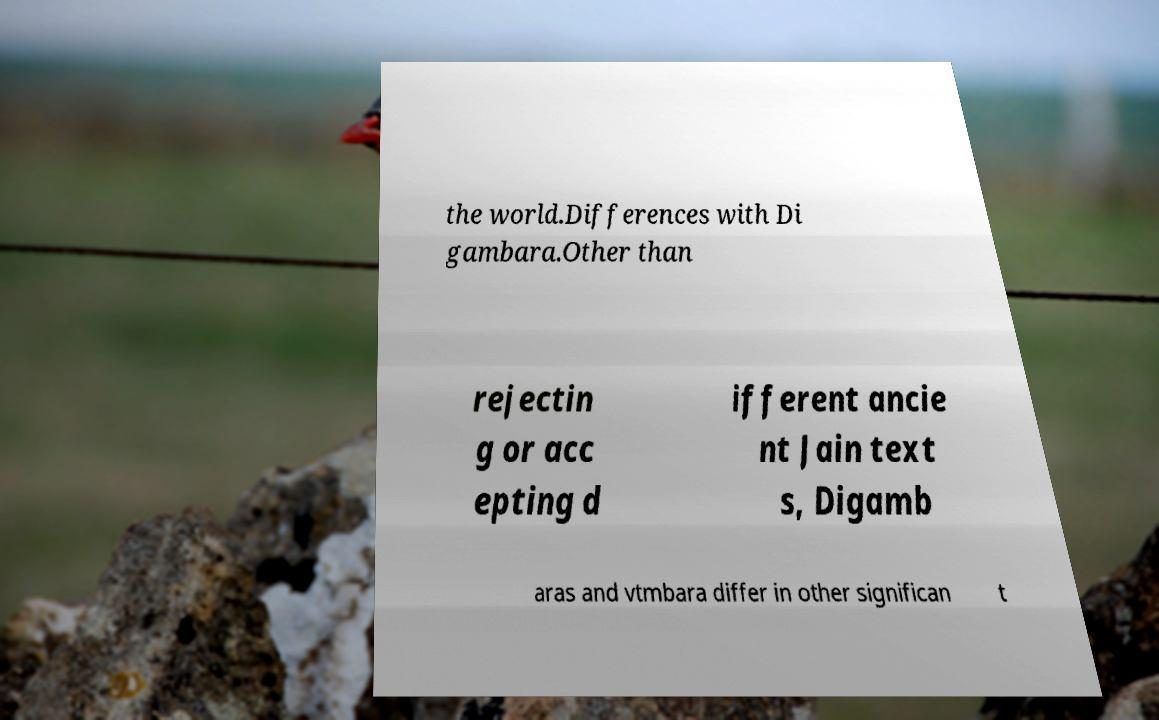Can you read and provide the text displayed in the image?This photo seems to have some interesting text. Can you extract and type it out for me? the world.Differences with Di gambara.Other than rejectin g or acc epting d ifferent ancie nt Jain text s, Digamb aras and vtmbara differ in other significan t 